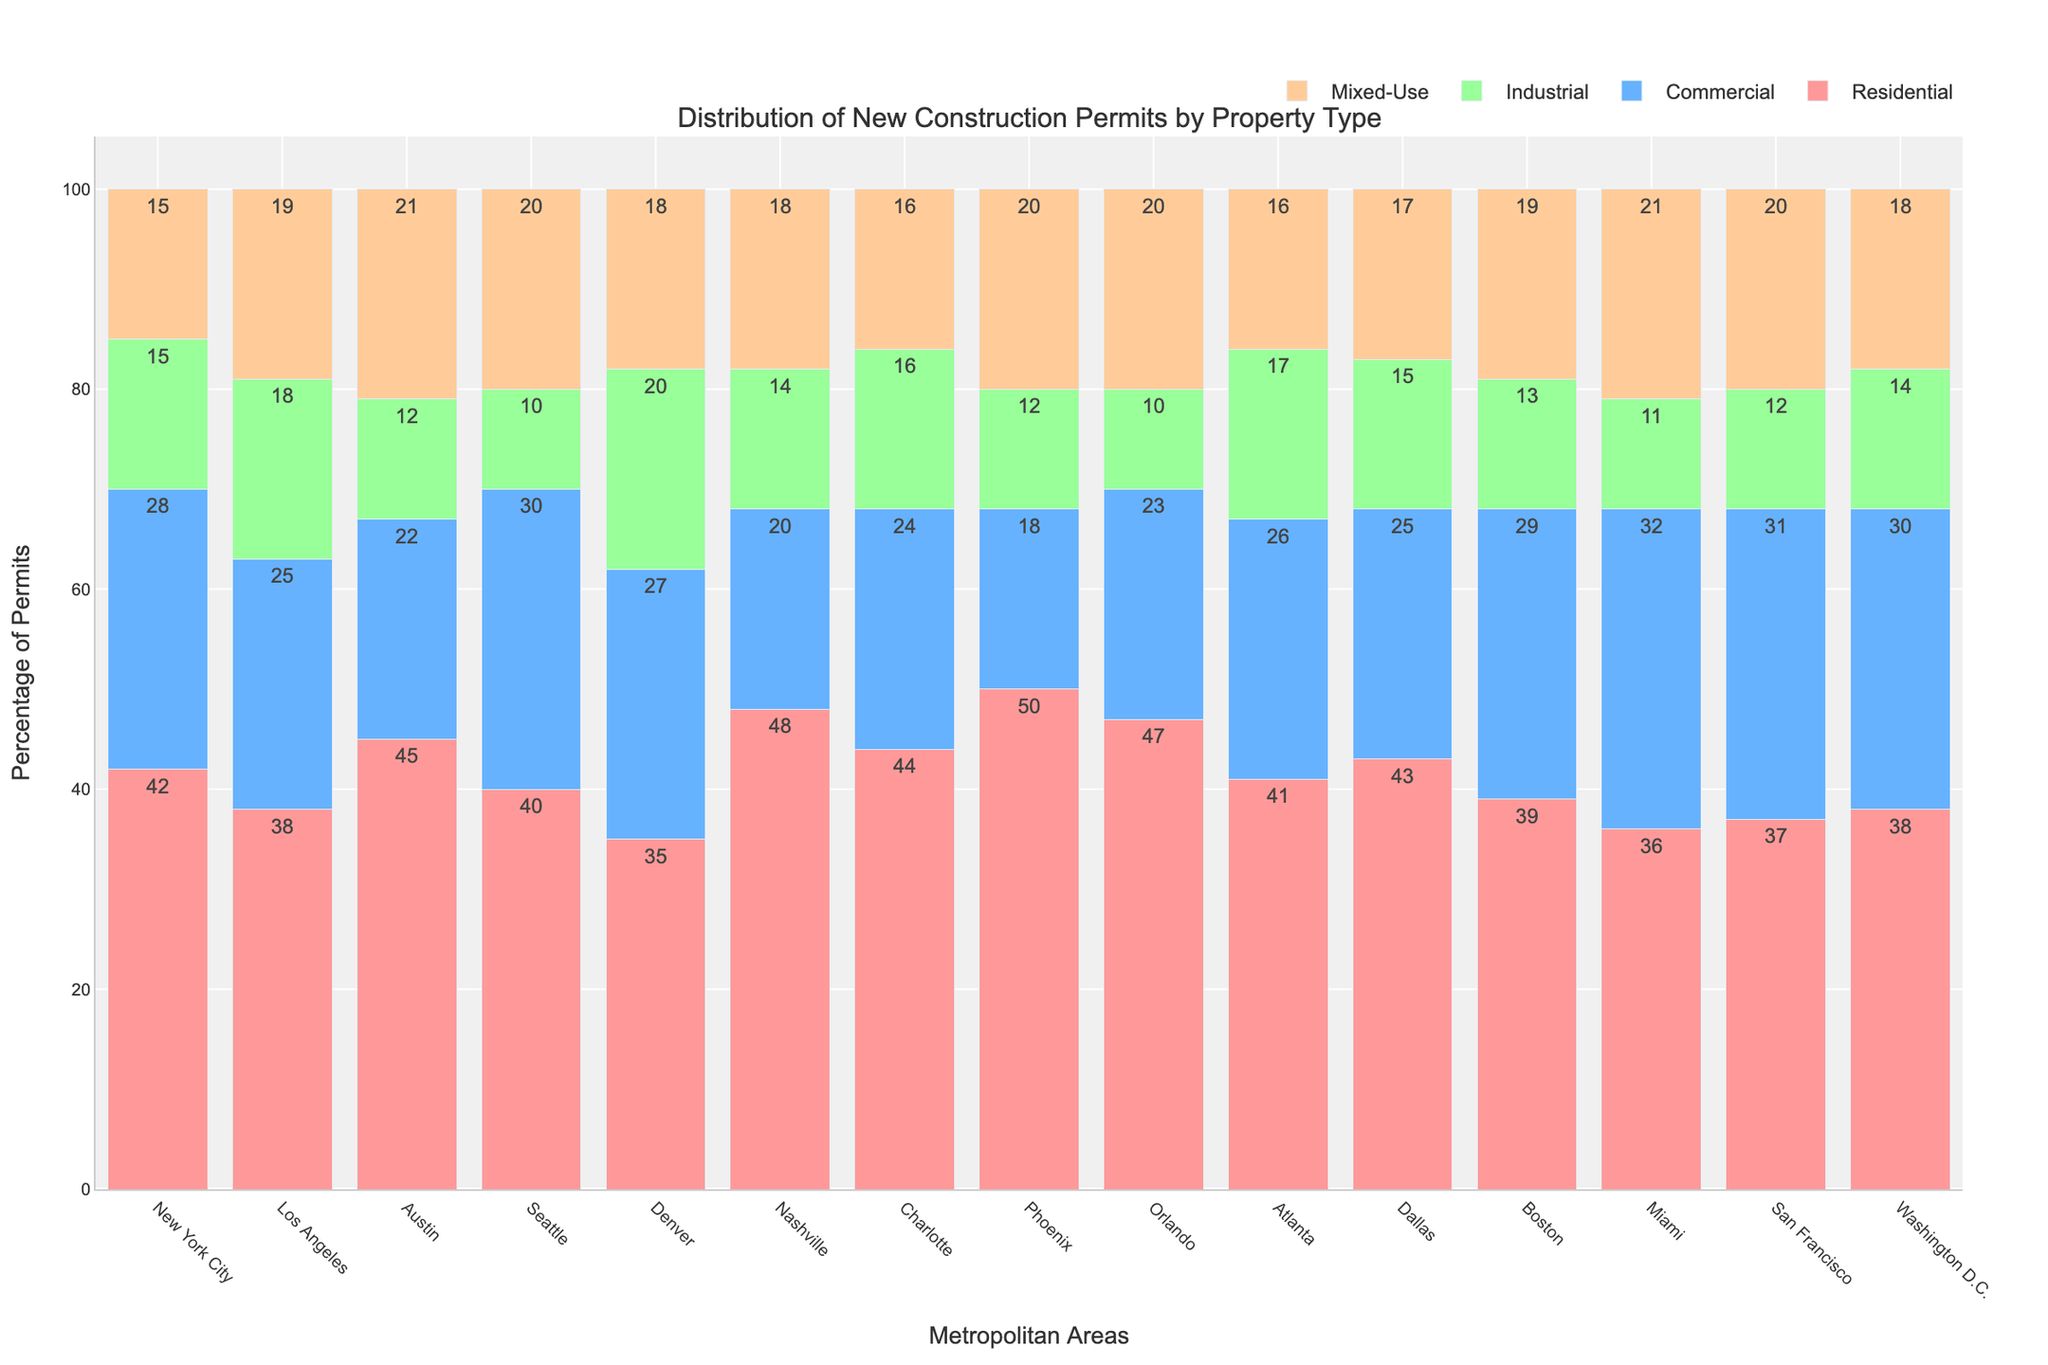Which metropolitan area has the highest number of residential permits? Look at the bar corresponding to residential permits for each city; the highest bar indicates the city with the most permits. Phoenix has the tallest bar for residential permits.
Answer: Phoenix Which city issued more commercial permits, Boston or Miami? Compare the height of the bars for commercial permits of Boston and Miami. Miami’s bar is taller.
Answer: Miami What is the total number of construction permits issued in Washington D.C.? Sum the values of all types of permits for Washington D.C.: 38 (Residential) + 30 (Commercial) + 14 (Industrial) + 18 (Mixed-Use).
Answer: 100 Which property type has the lowest number of permits in Austin? Compare the heights of the bars representing different property types for Austin; the shortest bar corresponds to the lowest number of permits.
Answer: Industrial Are residential permits more common in New York City or Los Angeles? Compare the height of the residential bars for New York City and Los Angeles. New York City's bar is slightly taller.
Answer: New York City Which city has an equal distribution of industrial and mixed-use permits? Look for a city with identical bar heights for industrial and mixed-use permits. New York City has equal heights for these categories.
Answer: New York City What is the difference in the number of residential permits between the city with the most and the city with the least residential permits? The city with the most residential permits is Phoenix with 50, and the least is Denver with 35. The difference is 50 - 35.
Answer: 15 In Orlando, which type of permit surpasses the others numerically? Compare the heights of all bars for Orlando; the tallest bar denotes the most permits.
Answer: Residential Is the number of mixed-use permits in Seattle greater than in Atlanta? Compare the mixed-use permit bars for Seattle and Atlanta. Seattle's bar is slightly taller.
Answer: Yes Which city has the second highest number of commercial permits? Identify the city with the second tallest bar for commercial permits. San Francisco has the second highest, just below Miami.
Answer: San Francisco 